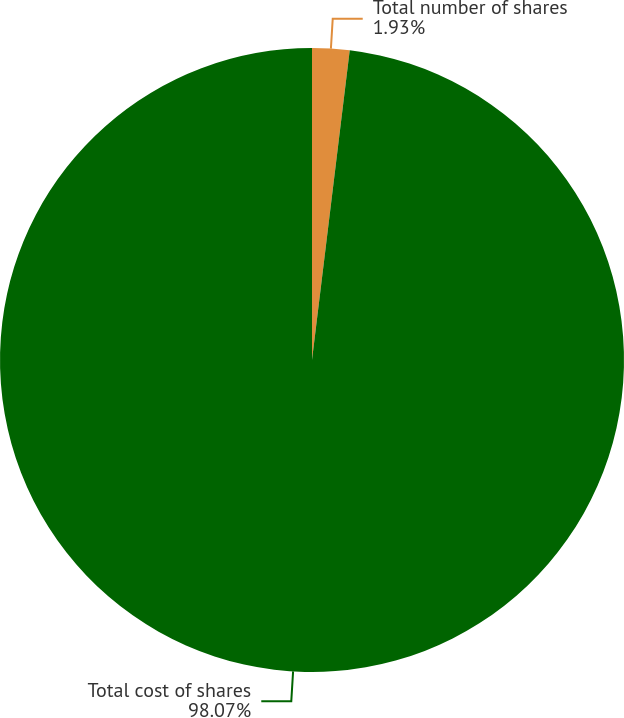Convert chart to OTSL. <chart><loc_0><loc_0><loc_500><loc_500><pie_chart><fcel>Total number of shares<fcel>Total cost of shares<nl><fcel>1.93%<fcel>98.07%<nl></chart> 